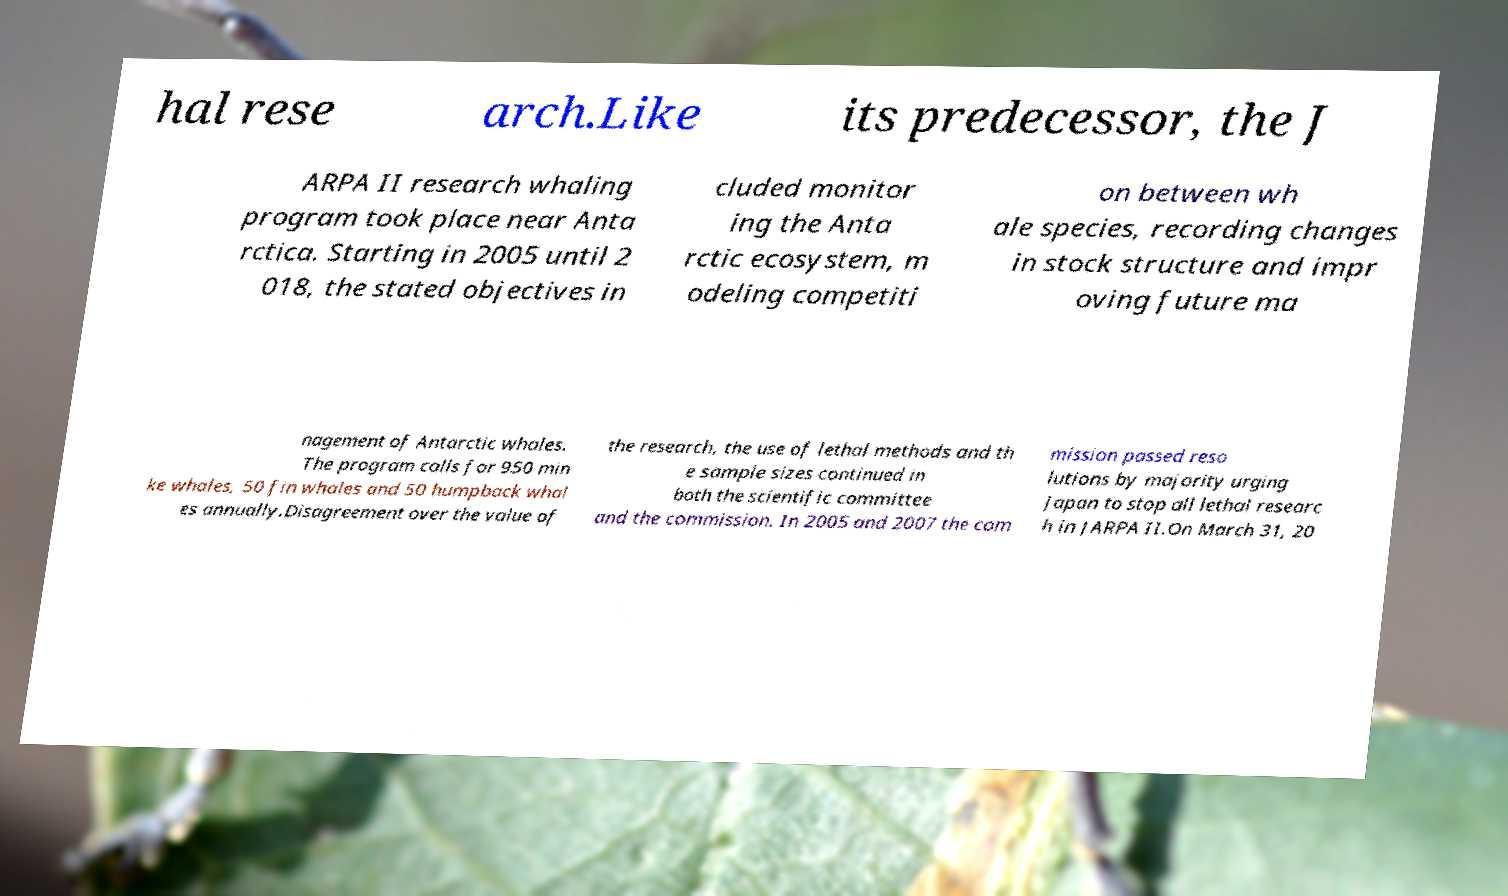What messages or text are displayed in this image? I need them in a readable, typed format. hal rese arch.Like its predecessor, the J ARPA II research whaling program took place near Anta rctica. Starting in 2005 until 2 018, the stated objectives in cluded monitor ing the Anta rctic ecosystem, m odeling competiti on between wh ale species, recording changes in stock structure and impr oving future ma nagement of Antarctic whales. The program calls for 950 min ke whales, 50 fin whales and 50 humpback whal es annually.Disagreement over the value of the research, the use of lethal methods and th e sample sizes continued in both the scientific committee and the commission. In 2005 and 2007 the com mission passed reso lutions by majority urging Japan to stop all lethal researc h in JARPA II.On March 31, 20 